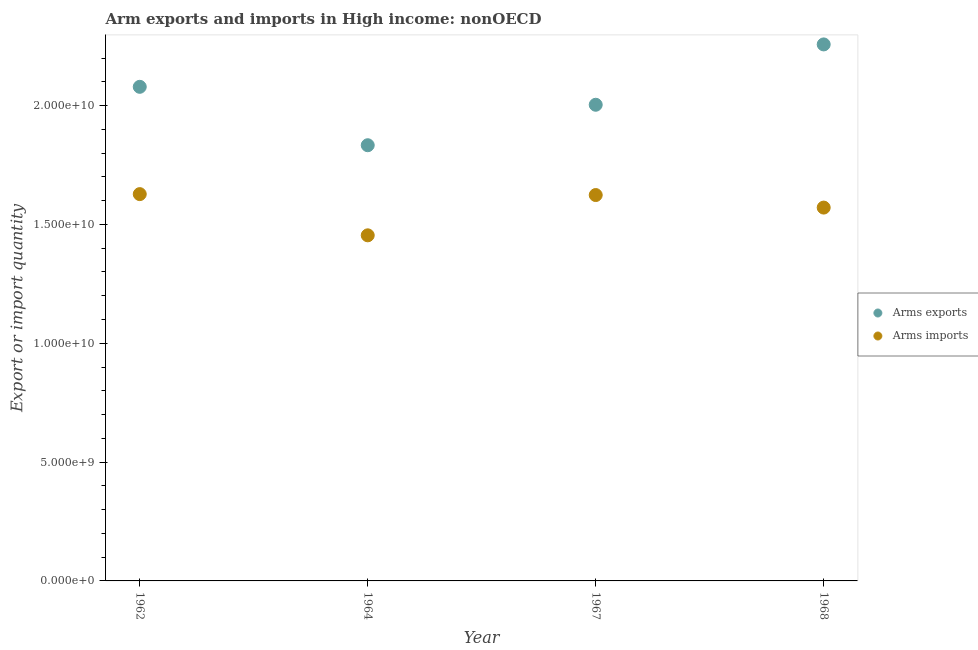How many different coloured dotlines are there?
Your answer should be very brief. 2. Is the number of dotlines equal to the number of legend labels?
Provide a succinct answer. Yes. What is the arms exports in 1962?
Ensure brevity in your answer.  2.08e+1. Across all years, what is the maximum arms exports?
Offer a terse response. 2.26e+1. Across all years, what is the minimum arms exports?
Your answer should be compact. 1.83e+1. In which year was the arms exports maximum?
Offer a very short reply. 1968. In which year was the arms exports minimum?
Provide a succinct answer. 1964. What is the total arms exports in the graph?
Ensure brevity in your answer.  8.17e+1. What is the difference between the arms exports in 1964 and that in 1968?
Give a very brief answer. -4.24e+09. What is the difference between the arms exports in 1962 and the arms imports in 1964?
Offer a terse response. 6.25e+09. What is the average arms exports per year?
Give a very brief answer. 2.04e+1. In the year 1968, what is the difference between the arms exports and arms imports?
Offer a terse response. 6.87e+09. What is the ratio of the arms exports in 1967 to that in 1968?
Provide a succinct answer. 0.89. Is the arms exports in 1962 less than that in 1964?
Give a very brief answer. No. Is the difference between the arms exports in 1967 and 1968 greater than the difference between the arms imports in 1967 and 1968?
Ensure brevity in your answer.  No. What is the difference between the highest and the second highest arms exports?
Keep it short and to the point. 1.78e+09. What is the difference between the highest and the lowest arms exports?
Ensure brevity in your answer.  4.24e+09. In how many years, is the arms imports greater than the average arms imports taken over all years?
Offer a very short reply. 3. Is the sum of the arms exports in 1962 and 1968 greater than the maximum arms imports across all years?
Offer a very short reply. Yes. Where does the legend appear in the graph?
Make the answer very short. Center right. How are the legend labels stacked?
Your response must be concise. Vertical. What is the title of the graph?
Your answer should be compact. Arm exports and imports in High income: nonOECD. Does "Male" appear as one of the legend labels in the graph?
Make the answer very short. No. What is the label or title of the X-axis?
Provide a short and direct response. Year. What is the label or title of the Y-axis?
Keep it short and to the point. Export or import quantity. What is the Export or import quantity in Arms exports in 1962?
Ensure brevity in your answer.  2.08e+1. What is the Export or import quantity in Arms imports in 1962?
Make the answer very short. 1.63e+1. What is the Export or import quantity of Arms exports in 1964?
Ensure brevity in your answer.  1.83e+1. What is the Export or import quantity of Arms imports in 1964?
Provide a succinct answer. 1.45e+1. What is the Export or import quantity of Arms exports in 1967?
Provide a succinct answer. 2.00e+1. What is the Export or import quantity of Arms imports in 1967?
Your response must be concise. 1.62e+1. What is the Export or import quantity of Arms exports in 1968?
Ensure brevity in your answer.  2.26e+1. What is the Export or import quantity in Arms imports in 1968?
Ensure brevity in your answer.  1.57e+1. Across all years, what is the maximum Export or import quantity in Arms exports?
Offer a terse response. 2.26e+1. Across all years, what is the maximum Export or import quantity in Arms imports?
Your answer should be compact. 1.63e+1. Across all years, what is the minimum Export or import quantity in Arms exports?
Offer a terse response. 1.83e+1. Across all years, what is the minimum Export or import quantity of Arms imports?
Provide a short and direct response. 1.45e+1. What is the total Export or import quantity in Arms exports in the graph?
Offer a very short reply. 8.17e+1. What is the total Export or import quantity in Arms imports in the graph?
Keep it short and to the point. 6.28e+1. What is the difference between the Export or import quantity in Arms exports in 1962 and that in 1964?
Offer a very short reply. 2.46e+09. What is the difference between the Export or import quantity in Arms imports in 1962 and that in 1964?
Keep it short and to the point. 1.73e+09. What is the difference between the Export or import quantity in Arms exports in 1962 and that in 1967?
Give a very brief answer. 7.55e+08. What is the difference between the Export or import quantity of Arms imports in 1962 and that in 1967?
Make the answer very short. 3.90e+07. What is the difference between the Export or import quantity of Arms exports in 1962 and that in 1968?
Provide a short and direct response. -1.78e+09. What is the difference between the Export or import quantity in Arms imports in 1962 and that in 1968?
Ensure brevity in your answer.  5.67e+08. What is the difference between the Export or import quantity in Arms exports in 1964 and that in 1967?
Give a very brief answer. -1.70e+09. What is the difference between the Export or import quantity in Arms imports in 1964 and that in 1967?
Provide a succinct answer. -1.70e+09. What is the difference between the Export or import quantity of Arms exports in 1964 and that in 1968?
Your answer should be very brief. -4.24e+09. What is the difference between the Export or import quantity of Arms imports in 1964 and that in 1968?
Your answer should be compact. -1.17e+09. What is the difference between the Export or import quantity in Arms exports in 1967 and that in 1968?
Your answer should be compact. -2.54e+09. What is the difference between the Export or import quantity in Arms imports in 1967 and that in 1968?
Give a very brief answer. 5.28e+08. What is the difference between the Export or import quantity of Arms exports in 1962 and the Export or import quantity of Arms imports in 1964?
Offer a terse response. 6.25e+09. What is the difference between the Export or import quantity of Arms exports in 1962 and the Export or import quantity of Arms imports in 1967?
Your answer should be compact. 4.55e+09. What is the difference between the Export or import quantity of Arms exports in 1962 and the Export or import quantity of Arms imports in 1968?
Offer a very short reply. 5.08e+09. What is the difference between the Export or import quantity in Arms exports in 1964 and the Export or import quantity in Arms imports in 1967?
Keep it short and to the point. 2.10e+09. What is the difference between the Export or import quantity of Arms exports in 1964 and the Export or import quantity of Arms imports in 1968?
Give a very brief answer. 2.62e+09. What is the difference between the Export or import quantity of Arms exports in 1967 and the Export or import quantity of Arms imports in 1968?
Make the answer very short. 4.33e+09. What is the average Export or import quantity in Arms exports per year?
Offer a very short reply. 2.04e+1. What is the average Export or import quantity of Arms imports per year?
Offer a very short reply. 1.57e+1. In the year 1962, what is the difference between the Export or import quantity of Arms exports and Export or import quantity of Arms imports?
Ensure brevity in your answer.  4.52e+09. In the year 1964, what is the difference between the Export or import quantity in Arms exports and Export or import quantity in Arms imports?
Your answer should be compact. 3.79e+09. In the year 1967, what is the difference between the Export or import quantity in Arms exports and Export or import quantity in Arms imports?
Provide a short and direct response. 3.80e+09. In the year 1968, what is the difference between the Export or import quantity of Arms exports and Export or import quantity of Arms imports?
Keep it short and to the point. 6.87e+09. What is the ratio of the Export or import quantity of Arms exports in 1962 to that in 1964?
Give a very brief answer. 1.13. What is the ratio of the Export or import quantity in Arms imports in 1962 to that in 1964?
Your answer should be very brief. 1.12. What is the ratio of the Export or import quantity in Arms exports in 1962 to that in 1967?
Your answer should be very brief. 1.04. What is the ratio of the Export or import quantity of Arms exports in 1962 to that in 1968?
Ensure brevity in your answer.  0.92. What is the ratio of the Export or import quantity in Arms imports in 1962 to that in 1968?
Provide a short and direct response. 1.04. What is the ratio of the Export or import quantity of Arms exports in 1964 to that in 1967?
Provide a succinct answer. 0.92. What is the ratio of the Export or import quantity of Arms imports in 1964 to that in 1967?
Your answer should be compact. 0.9. What is the ratio of the Export or import quantity of Arms exports in 1964 to that in 1968?
Provide a succinct answer. 0.81. What is the ratio of the Export or import quantity of Arms imports in 1964 to that in 1968?
Provide a short and direct response. 0.93. What is the ratio of the Export or import quantity in Arms exports in 1967 to that in 1968?
Make the answer very short. 0.89. What is the ratio of the Export or import quantity in Arms imports in 1967 to that in 1968?
Offer a terse response. 1.03. What is the difference between the highest and the second highest Export or import quantity in Arms exports?
Your response must be concise. 1.78e+09. What is the difference between the highest and the second highest Export or import quantity in Arms imports?
Offer a very short reply. 3.90e+07. What is the difference between the highest and the lowest Export or import quantity in Arms exports?
Keep it short and to the point. 4.24e+09. What is the difference between the highest and the lowest Export or import quantity in Arms imports?
Ensure brevity in your answer.  1.73e+09. 